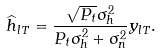Convert formula to latex. <formula><loc_0><loc_0><loc_500><loc_500>\widehat { h } _ { l T } = \frac { \sqrt { P _ { t } } \sigma _ { h } ^ { 2 } } { P _ { t } \sigma _ { h } ^ { 2 } + \sigma _ { n } ^ { 2 } } y _ { l T } .</formula> 